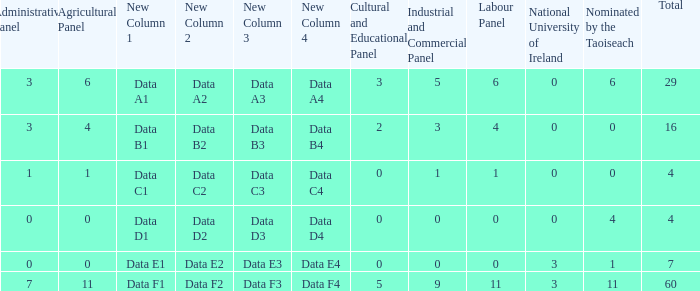What is the average agricultural panel of the composition with a labour panel less than 6, more than 0 nominations by Taoiseach, and a total less than 4? None. 